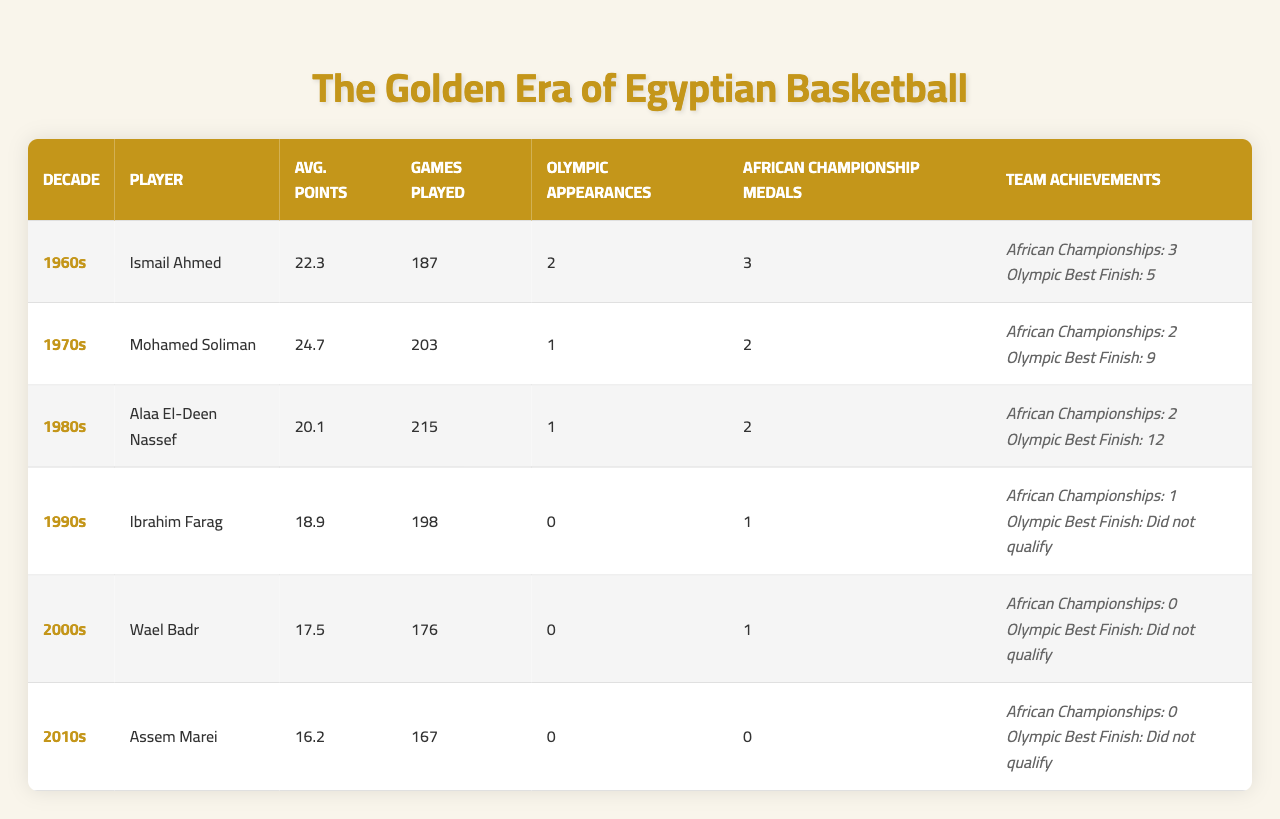What is the highest average points per game in the table? The highest average points per game is for Mohamed Soliman in the 1970s with 24.7 points.
Answer: 24.7 Who played the most total games in the 1980s? Alaa El-Deen Nassef played the most total games in the 1980s with 215 games.
Answer: Alaa El-Deen Nassef How many Olympic appearances did Ismail Ahmed have? Ismail Ahmed had 2 Olympic appearances, as stated in the table.
Answer: 2 Which player had no Olympic appearances? The players with no Olympic appearances are Ibrahim Farag, Wael Badr, and Assem Marei.
Answer: Ibrahim Farag, Wael Badr, Assem Marei What is the average points per game for the players in the 2000s decade? The average points per game for Wael Badr is 17.5; he is the only player in the 2000s decade.
Answer: 17.5 Did any player in the 2010s win African Championship medals? No, Assem Marei, the player from the 2010s, did not win any African Championship medals.
Answer: No Which decade had the highest number of African Championship titles? The 1960s had the highest number of African Championship titles with 3 titles.
Answer: 1960s What is the difference in average points per game between the 1970s and 1990s? Mohamed Soliman averaged 24.7 points in the 1970s, while Ibrahim Farag averaged 18.9 points in the 1990s. The difference is 24.7 - 18.9 = 5.8 points.
Answer: 5.8 True or false: The Egyptian basketball team won African Championship titles in both the 2000s and 2010s. False, the Egyptian basketball team did not win any African Championship titles in the 2000s and 2010s.
Answer: False Which player had the lowest average points per game, and what was it? Assem Marei had the lowest average points per game with 16.2 points.
Answer: Assem Marei, 16.2 